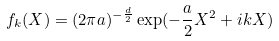<formula> <loc_0><loc_0><loc_500><loc_500>f _ { k } ( { X } ) = ( 2 \pi a ) ^ { - \frac { d } { 2 } } \exp ( - \frac { a } { 2 } { X } ^ { 2 } + i { k } { X } )</formula> 